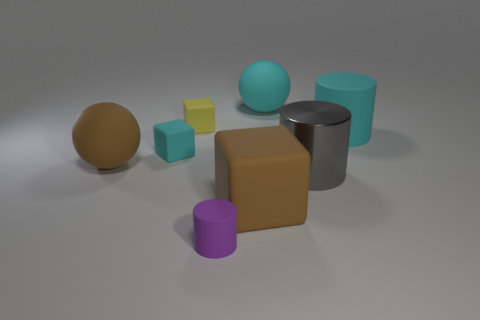Is there a large rubber thing that has the same shape as the tiny cyan thing?
Ensure brevity in your answer.  Yes. How many gray things have the same material as the large cyan ball?
Your answer should be very brief. 0. Does the big cylinder right of the big shiny object have the same material as the gray cylinder?
Your answer should be very brief. No. Are there more big brown rubber objects right of the purple matte thing than small cyan rubber objects that are in front of the brown matte cube?
Provide a succinct answer. Yes. There is a cyan thing that is the same size as the cyan rubber sphere; what is it made of?
Keep it short and to the point. Rubber. How many other things are the same material as the large gray object?
Offer a very short reply. 0. Does the rubber thing that is in front of the big cube have the same shape as the big brown rubber thing that is on the left side of the small purple cylinder?
Give a very brief answer. No. What number of other things are the same color as the big metal cylinder?
Make the answer very short. 0. Does the brown ball that is behind the small purple object have the same material as the large cylinder that is left of the large matte cylinder?
Provide a short and direct response. No. Is the number of yellow rubber cubes behind the large cyan rubber ball the same as the number of purple matte objects behind the cyan block?
Ensure brevity in your answer.  Yes. 